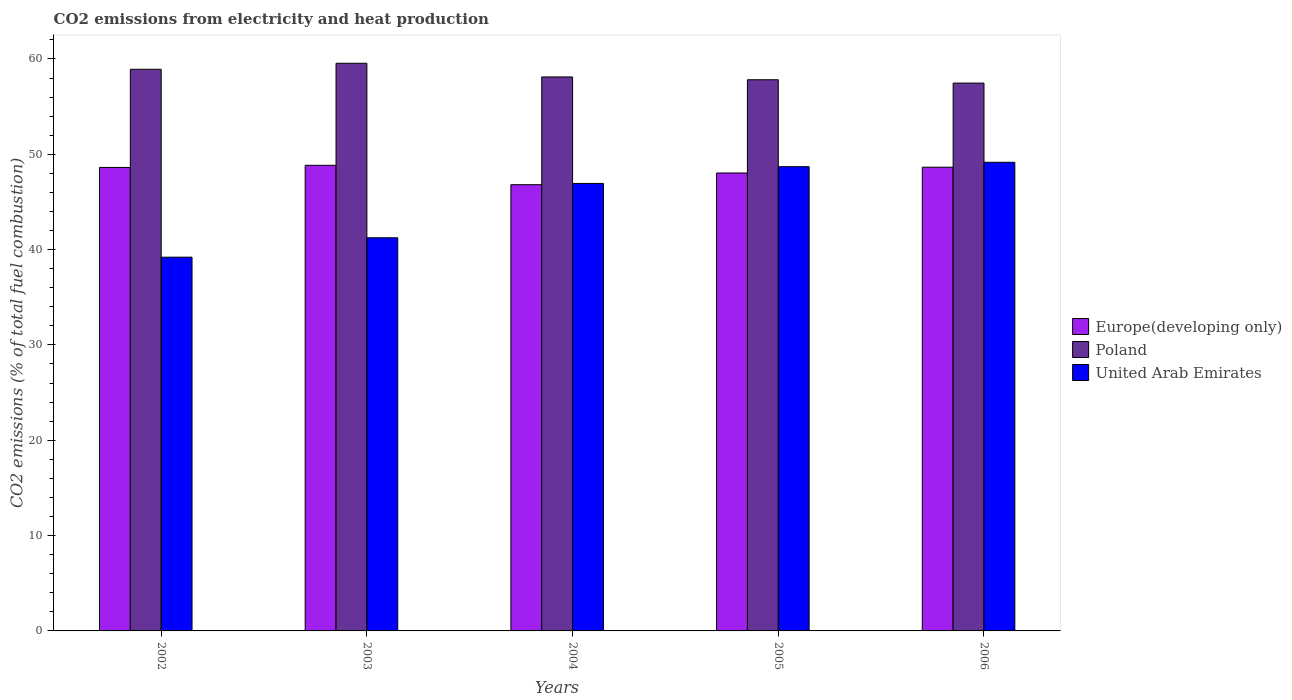How many different coloured bars are there?
Provide a succinct answer. 3. Are the number of bars on each tick of the X-axis equal?
Offer a very short reply. Yes. How many bars are there on the 1st tick from the right?
Ensure brevity in your answer.  3. What is the label of the 3rd group of bars from the left?
Your answer should be very brief. 2004. In how many cases, is the number of bars for a given year not equal to the number of legend labels?
Provide a succinct answer. 0. What is the amount of CO2 emitted in Poland in 2006?
Your answer should be very brief. 57.47. Across all years, what is the maximum amount of CO2 emitted in Europe(developing only)?
Provide a succinct answer. 48.84. Across all years, what is the minimum amount of CO2 emitted in Poland?
Make the answer very short. 57.47. In which year was the amount of CO2 emitted in Poland maximum?
Give a very brief answer. 2003. In which year was the amount of CO2 emitted in Europe(developing only) minimum?
Ensure brevity in your answer.  2004. What is the total amount of CO2 emitted in United Arab Emirates in the graph?
Provide a succinct answer. 225.24. What is the difference between the amount of CO2 emitted in Europe(developing only) in 2002 and that in 2005?
Your response must be concise. 0.58. What is the difference between the amount of CO2 emitted in United Arab Emirates in 2005 and the amount of CO2 emitted in Europe(developing only) in 2003?
Provide a short and direct response. -0.14. What is the average amount of CO2 emitted in Poland per year?
Your answer should be compact. 58.37. In the year 2003, what is the difference between the amount of CO2 emitted in United Arab Emirates and amount of CO2 emitted in Europe(developing only)?
Give a very brief answer. -7.6. In how many years, is the amount of CO2 emitted in Poland greater than 40 %?
Your answer should be compact. 5. What is the ratio of the amount of CO2 emitted in Europe(developing only) in 2003 to that in 2006?
Keep it short and to the point. 1. Is the amount of CO2 emitted in Poland in 2002 less than that in 2003?
Keep it short and to the point. Yes. Is the difference between the amount of CO2 emitted in United Arab Emirates in 2003 and 2005 greater than the difference between the amount of CO2 emitted in Europe(developing only) in 2003 and 2005?
Give a very brief answer. No. What is the difference between the highest and the second highest amount of CO2 emitted in Europe(developing only)?
Offer a terse response. 0.2. What is the difference between the highest and the lowest amount of CO2 emitted in Poland?
Provide a short and direct response. 2.08. In how many years, is the amount of CO2 emitted in Europe(developing only) greater than the average amount of CO2 emitted in Europe(developing only) taken over all years?
Offer a very short reply. 3. Is the sum of the amount of CO2 emitted in United Arab Emirates in 2003 and 2004 greater than the maximum amount of CO2 emitted in Europe(developing only) across all years?
Offer a terse response. Yes. What does the 2nd bar from the left in 2006 represents?
Provide a short and direct response. Poland. What does the 3rd bar from the right in 2004 represents?
Your answer should be compact. Europe(developing only). Is it the case that in every year, the sum of the amount of CO2 emitted in Europe(developing only) and amount of CO2 emitted in Poland is greater than the amount of CO2 emitted in United Arab Emirates?
Give a very brief answer. Yes. How many bars are there?
Keep it short and to the point. 15. Are all the bars in the graph horizontal?
Keep it short and to the point. No. How many years are there in the graph?
Provide a short and direct response. 5. Are the values on the major ticks of Y-axis written in scientific E-notation?
Provide a succinct answer. No. Does the graph contain grids?
Offer a very short reply. No. How many legend labels are there?
Offer a terse response. 3. How are the legend labels stacked?
Make the answer very short. Vertical. What is the title of the graph?
Keep it short and to the point. CO2 emissions from electricity and heat production. What is the label or title of the Y-axis?
Your answer should be compact. CO2 emissions (% of total fuel combustion). What is the CO2 emissions (% of total fuel combustion) in Europe(developing only) in 2002?
Make the answer very short. 48.62. What is the CO2 emissions (% of total fuel combustion) of Poland in 2002?
Offer a terse response. 58.92. What is the CO2 emissions (% of total fuel combustion) in United Arab Emirates in 2002?
Your response must be concise. 39.2. What is the CO2 emissions (% of total fuel combustion) of Europe(developing only) in 2003?
Give a very brief answer. 48.84. What is the CO2 emissions (% of total fuel combustion) in Poland in 2003?
Your response must be concise. 59.55. What is the CO2 emissions (% of total fuel combustion) in United Arab Emirates in 2003?
Keep it short and to the point. 41.24. What is the CO2 emissions (% of total fuel combustion) in Europe(developing only) in 2004?
Keep it short and to the point. 46.81. What is the CO2 emissions (% of total fuel combustion) in Poland in 2004?
Offer a very short reply. 58.11. What is the CO2 emissions (% of total fuel combustion) of United Arab Emirates in 2004?
Provide a succinct answer. 46.94. What is the CO2 emissions (% of total fuel combustion) in Europe(developing only) in 2005?
Keep it short and to the point. 48.04. What is the CO2 emissions (% of total fuel combustion) in Poland in 2005?
Make the answer very short. 57.82. What is the CO2 emissions (% of total fuel combustion) of United Arab Emirates in 2005?
Your answer should be very brief. 48.7. What is the CO2 emissions (% of total fuel combustion) of Europe(developing only) in 2006?
Offer a terse response. 48.64. What is the CO2 emissions (% of total fuel combustion) of Poland in 2006?
Offer a terse response. 57.47. What is the CO2 emissions (% of total fuel combustion) in United Arab Emirates in 2006?
Offer a very short reply. 49.16. Across all years, what is the maximum CO2 emissions (% of total fuel combustion) in Europe(developing only)?
Your response must be concise. 48.84. Across all years, what is the maximum CO2 emissions (% of total fuel combustion) of Poland?
Give a very brief answer. 59.55. Across all years, what is the maximum CO2 emissions (% of total fuel combustion) of United Arab Emirates?
Make the answer very short. 49.16. Across all years, what is the minimum CO2 emissions (% of total fuel combustion) of Europe(developing only)?
Your answer should be compact. 46.81. Across all years, what is the minimum CO2 emissions (% of total fuel combustion) in Poland?
Your answer should be compact. 57.47. Across all years, what is the minimum CO2 emissions (% of total fuel combustion) in United Arab Emirates?
Provide a short and direct response. 39.2. What is the total CO2 emissions (% of total fuel combustion) in Europe(developing only) in the graph?
Keep it short and to the point. 240.95. What is the total CO2 emissions (% of total fuel combustion) of Poland in the graph?
Your answer should be very brief. 291.86. What is the total CO2 emissions (% of total fuel combustion) in United Arab Emirates in the graph?
Keep it short and to the point. 225.24. What is the difference between the CO2 emissions (% of total fuel combustion) in Europe(developing only) in 2002 and that in 2003?
Offer a terse response. -0.22. What is the difference between the CO2 emissions (% of total fuel combustion) in Poland in 2002 and that in 2003?
Make the answer very short. -0.63. What is the difference between the CO2 emissions (% of total fuel combustion) in United Arab Emirates in 2002 and that in 2003?
Your answer should be compact. -2.04. What is the difference between the CO2 emissions (% of total fuel combustion) in Europe(developing only) in 2002 and that in 2004?
Ensure brevity in your answer.  1.81. What is the difference between the CO2 emissions (% of total fuel combustion) of Poland in 2002 and that in 2004?
Your answer should be compact. 0.81. What is the difference between the CO2 emissions (% of total fuel combustion) of United Arab Emirates in 2002 and that in 2004?
Provide a succinct answer. -7.74. What is the difference between the CO2 emissions (% of total fuel combustion) of Europe(developing only) in 2002 and that in 2005?
Provide a short and direct response. 0.58. What is the difference between the CO2 emissions (% of total fuel combustion) of Poland in 2002 and that in 2005?
Keep it short and to the point. 1.1. What is the difference between the CO2 emissions (% of total fuel combustion) in United Arab Emirates in 2002 and that in 2005?
Ensure brevity in your answer.  -9.49. What is the difference between the CO2 emissions (% of total fuel combustion) of Europe(developing only) in 2002 and that in 2006?
Provide a succinct answer. -0.02. What is the difference between the CO2 emissions (% of total fuel combustion) in Poland in 2002 and that in 2006?
Your answer should be compact. 1.45. What is the difference between the CO2 emissions (% of total fuel combustion) in United Arab Emirates in 2002 and that in 2006?
Ensure brevity in your answer.  -9.95. What is the difference between the CO2 emissions (% of total fuel combustion) in Europe(developing only) in 2003 and that in 2004?
Provide a short and direct response. 2.03. What is the difference between the CO2 emissions (% of total fuel combustion) of Poland in 2003 and that in 2004?
Offer a very short reply. 1.44. What is the difference between the CO2 emissions (% of total fuel combustion) of United Arab Emirates in 2003 and that in 2004?
Offer a terse response. -5.7. What is the difference between the CO2 emissions (% of total fuel combustion) of Europe(developing only) in 2003 and that in 2005?
Offer a very short reply. 0.81. What is the difference between the CO2 emissions (% of total fuel combustion) of Poland in 2003 and that in 2005?
Offer a very short reply. 1.73. What is the difference between the CO2 emissions (% of total fuel combustion) in United Arab Emirates in 2003 and that in 2005?
Offer a very short reply. -7.46. What is the difference between the CO2 emissions (% of total fuel combustion) of Europe(developing only) in 2003 and that in 2006?
Keep it short and to the point. 0.2. What is the difference between the CO2 emissions (% of total fuel combustion) in Poland in 2003 and that in 2006?
Provide a succinct answer. 2.08. What is the difference between the CO2 emissions (% of total fuel combustion) in United Arab Emirates in 2003 and that in 2006?
Provide a succinct answer. -7.92. What is the difference between the CO2 emissions (% of total fuel combustion) of Europe(developing only) in 2004 and that in 2005?
Your answer should be very brief. -1.23. What is the difference between the CO2 emissions (% of total fuel combustion) of Poland in 2004 and that in 2005?
Provide a succinct answer. 0.29. What is the difference between the CO2 emissions (% of total fuel combustion) of United Arab Emirates in 2004 and that in 2005?
Keep it short and to the point. -1.76. What is the difference between the CO2 emissions (% of total fuel combustion) of Europe(developing only) in 2004 and that in 2006?
Your response must be concise. -1.83. What is the difference between the CO2 emissions (% of total fuel combustion) in Poland in 2004 and that in 2006?
Provide a succinct answer. 0.64. What is the difference between the CO2 emissions (% of total fuel combustion) of United Arab Emirates in 2004 and that in 2006?
Offer a very short reply. -2.22. What is the difference between the CO2 emissions (% of total fuel combustion) of Europe(developing only) in 2005 and that in 2006?
Make the answer very short. -0.61. What is the difference between the CO2 emissions (% of total fuel combustion) in Poland in 2005 and that in 2006?
Your answer should be compact. 0.35. What is the difference between the CO2 emissions (% of total fuel combustion) in United Arab Emirates in 2005 and that in 2006?
Keep it short and to the point. -0.46. What is the difference between the CO2 emissions (% of total fuel combustion) of Europe(developing only) in 2002 and the CO2 emissions (% of total fuel combustion) of Poland in 2003?
Make the answer very short. -10.93. What is the difference between the CO2 emissions (% of total fuel combustion) of Europe(developing only) in 2002 and the CO2 emissions (% of total fuel combustion) of United Arab Emirates in 2003?
Your answer should be compact. 7.38. What is the difference between the CO2 emissions (% of total fuel combustion) in Poland in 2002 and the CO2 emissions (% of total fuel combustion) in United Arab Emirates in 2003?
Offer a very short reply. 17.68. What is the difference between the CO2 emissions (% of total fuel combustion) of Europe(developing only) in 2002 and the CO2 emissions (% of total fuel combustion) of Poland in 2004?
Offer a very short reply. -9.49. What is the difference between the CO2 emissions (% of total fuel combustion) in Europe(developing only) in 2002 and the CO2 emissions (% of total fuel combustion) in United Arab Emirates in 2004?
Your answer should be compact. 1.68. What is the difference between the CO2 emissions (% of total fuel combustion) of Poland in 2002 and the CO2 emissions (% of total fuel combustion) of United Arab Emirates in 2004?
Provide a succinct answer. 11.97. What is the difference between the CO2 emissions (% of total fuel combustion) of Europe(developing only) in 2002 and the CO2 emissions (% of total fuel combustion) of Poland in 2005?
Keep it short and to the point. -9.2. What is the difference between the CO2 emissions (% of total fuel combustion) in Europe(developing only) in 2002 and the CO2 emissions (% of total fuel combustion) in United Arab Emirates in 2005?
Offer a terse response. -0.08. What is the difference between the CO2 emissions (% of total fuel combustion) in Poland in 2002 and the CO2 emissions (% of total fuel combustion) in United Arab Emirates in 2005?
Make the answer very short. 10.22. What is the difference between the CO2 emissions (% of total fuel combustion) in Europe(developing only) in 2002 and the CO2 emissions (% of total fuel combustion) in Poland in 2006?
Give a very brief answer. -8.85. What is the difference between the CO2 emissions (% of total fuel combustion) of Europe(developing only) in 2002 and the CO2 emissions (% of total fuel combustion) of United Arab Emirates in 2006?
Provide a succinct answer. -0.54. What is the difference between the CO2 emissions (% of total fuel combustion) in Poland in 2002 and the CO2 emissions (% of total fuel combustion) in United Arab Emirates in 2006?
Your response must be concise. 9.76. What is the difference between the CO2 emissions (% of total fuel combustion) of Europe(developing only) in 2003 and the CO2 emissions (% of total fuel combustion) of Poland in 2004?
Ensure brevity in your answer.  -9.27. What is the difference between the CO2 emissions (% of total fuel combustion) of Europe(developing only) in 2003 and the CO2 emissions (% of total fuel combustion) of United Arab Emirates in 2004?
Your response must be concise. 1.9. What is the difference between the CO2 emissions (% of total fuel combustion) in Poland in 2003 and the CO2 emissions (% of total fuel combustion) in United Arab Emirates in 2004?
Offer a very short reply. 12.61. What is the difference between the CO2 emissions (% of total fuel combustion) of Europe(developing only) in 2003 and the CO2 emissions (% of total fuel combustion) of Poland in 2005?
Give a very brief answer. -8.97. What is the difference between the CO2 emissions (% of total fuel combustion) in Europe(developing only) in 2003 and the CO2 emissions (% of total fuel combustion) in United Arab Emirates in 2005?
Give a very brief answer. 0.14. What is the difference between the CO2 emissions (% of total fuel combustion) in Poland in 2003 and the CO2 emissions (% of total fuel combustion) in United Arab Emirates in 2005?
Keep it short and to the point. 10.85. What is the difference between the CO2 emissions (% of total fuel combustion) in Europe(developing only) in 2003 and the CO2 emissions (% of total fuel combustion) in Poland in 2006?
Ensure brevity in your answer.  -8.62. What is the difference between the CO2 emissions (% of total fuel combustion) in Europe(developing only) in 2003 and the CO2 emissions (% of total fuel combustion) in United Arab Emirates in 2006?
Your response must be concise. -0.32. What is the difference between the CO2 emissions (% of total fuel combustion) of Poland in 2003 and the CO2 emissions (% of total fuel combustion) of United Arab Emirates in 2006?
Offer a very short reply. 10.39. What is the difference between the CO2 emissions (% of total fuel combustion) in Europe(developing only) in 2004 and the CO2 emissions (% of total fuel combustion) in Poland in 2005?
Ensure brevity in your answer.  -11.01. What is the difference between the CO2 emissions (% of total fuel combustion) in Europe(developing only) in 2004 and the CO2 emissions (% of total fuel combustion) in United Arab Emirates in 2005?
Offer a terse response. -1.89. What is the difference between the CO2 emissions (% of total fuel combustion) in Poland in 2004 and the CO2 emissions (% of total fuel combustion) in United Arab Emirates in 2005?
Your answer should be compact. 9.41. What is the difference between the CO2 emissions (% of total fuel combustion) in Europe(developing only) in 2004 and the CO2 emissions (% of total fuel combustion) in Poland in 2006?
Offer a terse response. -10.66. What is the difference between the CO2 emissions (% of total fuel combustion) of Europe(developing only) in 2004 and the CO2 emissions (% of total fuel combustion) of United Arab Emirates in 2006?
Your answer should be very brief. -2.35. What is the difference between the CO2 emissions (% of total fuel combustion) of Poland in 2004 and the CO2 emissions (% of total fuel combustion) of United Arab Emirates in 2006?
Provide a succinct answer. 8.95. What is the difference between the CO2 emissions (% of total fuel combustion) of Europe(developing only) in 2005 and the CO2 emissions (% of total fuel combustion) of Poland in 2006?
Offer a terse response. -9.43. What is the difference between the CO2 emissions (% of total fuel combustion) in Europe(developing only) in 2005 and the CO2 emissions (% of total fuel combustion) in United Arab Emirates in 2006?
Your response must be concise. -1.12. What is the difference between the CO2 emissions (% of total fuel combustion) in Poland in 2005 and the CO2 emissions (% of total fuel combustion) in United Arab Emirates in 2006?
Ensure brevity in your answer.  8.66. What is the average CO2 emissions (% of total fuel combustion) of Europe(developing only) per year?
Offer a very short reply. 48.19. What is the average CO2 emissions (% of total fuel combustion) of Poland per year?
Provide a short and direct response. 58.37. What is the average CO2 emissions (% of total fuel combustion) in United Arab Emirates per year?
Ensure brevity in your answer.  45.05. In the year 2002, what is the difference between the CO2 emissions (% of total fuel combustion) in Europe(developing only) and CO2 emissions (% of total fuel combustion) in Poland?
Your answer should be compact. -10.3. In the year 2002, what is the difference between the CO2 emissions (% of total fuel combustion) of Europe(developing only) and CO2 emissions (% of total fuel combustion) of United Arab Emirates?
Keep it short and to the point. 9.41. In the year 2002, what is the difference between the CO2 emissions (% of total fuel combustion) in Poland and CO2 emissions (% of total fuel combustion) in United Arab Emirates?
Provide a succinct answer. 19.71. In the year 2003, what is the difference between the CO2 emissions (% of total fuel combustion) in Europe(developing only) and CO2 emissions (% of total fuel combustion) in Poland?
Provide a succinct answer. -10.7. In the year 2003, what is the difference between the CO2 emissions (% of total fuel combustion) in Europe(developing only) and CO2 emissions (% of total fuel combustion) in United Arab Emirates?
Keep it short and to the point. 7.6. In the year 2003, what is the difference between the CO2 emissions (% of total fuel combustion) of Poland and CO2 emissions (% of total fuel combustion) of United Arab Emirates?
Provide a short and direct response. 18.31. In the year 2004, what is the difference between the CO2 emissions (% of total fuel combustion) of Europe(developing only) and CO2 emissions (% of total fuel combustion) of Poland?
Provide a short and direct response. -11.3. In the year 2004, what is the difference between the CO2 emissions (% of total fuel combustion) of Europe(developing only) and CO2 emissions (% of total fuel combustion) of United Arab Emirates?
Ensure brevity in your answer.  -0.13. In the year 2004, what is the difference between the CO2 emissions (% of total fuel combustion) of Poland and CO2 emissions (% of total fuel combustion) of United Arab Emirates?
Ensure brevity in your answer.  11.17. In the year 2005, what is the difference between the CO2 emissions (% of total fuel combustion) in Europe(developing only) and CO2 emissions (% of total fuel combustion) in Poland?
Provide a short and direct response. -9.78. In the year 2005, what is the difference between the CO2 emissions (% of total fuel combustion) in Europe(developing only) and CO2 emissions (% of total fuel combustion) in United Arab Emirates?
Provide a short and direct response. -0.66. In the year 2005, what is the difference between the CO2 emissions (% of total fuel combustion) in Poland and CO2 emissions (% of total fuel combustion) in United Arab Emirates?
Provide a succinct answer. 9.12. In the year 2006, what is the difference between the CO2 emissions (% of total fuel combustion) of Europe(developing only) and CO2 emissions (% of total fuel combustion) of Poland?
Offer a very short reply. -8.82. In the year 2006, what is the difference between the CO2 emissions (% of total fuel combustion) in Europe(developing only) and CO2 emissions (% of total fuel combustion) in United Arab Emirates?
Provide a succinct answer. -0.52. In the year 2006, what is the difference between the CO2 emissions (% of total fuel combustion) of Poland and CO2 emissions (% of total fuel combustion) of United Arab Emirates?
Your answer should be very brief. 8.31. What is the ratio of the CO2 emissions (% of total fuel combustion) in Europe(developing only) in 2002 to that in 2003?
Offer a terse response. 1. What is the ratio of the CO2 emissions (% of total fuel combustion) of Poland in 2002 to that in 2003?
Your answer should be very brief. 0.99. What is the ratio of the CO2 emissions (% of total fuel combustion) in United Arab Emirates in 2002 to that in 2003?
Your answer should be very brief. 0.95. What is the ratio of the CO2 emissions (% of total fuel combustion) of Europe(developing only) in 2002 to that in 2004?
Your response must be concise. 1.04. What is the ratio of the CO2 emissions (% of total fuel combustion) of Poland in 2002 to that in 2004?
Your answer should be compact. 1.01. What is the ratio of the CO2 emissions (% of total fuel combustion) in United Arab Emirates in 2002 to that in 2004?
Your answer should be very brief. 0.84. What is the ratio of the CO2 emissions (% of total fuel combustion) in Europe(developing only) in 2002 to that in 2005?
Offer a terse response. 1.01. What is the ratio of the CO2 emissions (% of total fuel combustion) of United Arab Emirates in 2002 to that in 2005?
Ensure brevity in your answer.  0.81. What is the ratio of the CO2 emissions (% of total fuel combustion) in Europe(developing only) in 2002 to that in 2006?
Make the answer very short. 1. What is the ratio of the CO2 emissions (% of total fuel combustion) in Poland in 2002 to that in 2006?
Provide a short and direct response. 1.03. What is the ratio of the CO2 emissions (% of total fuel combustion) in United Arab Emirates in 2002 to that in 2006?
Your answer should be compact. 0.8. What is the ratio of the CO2 emissions (% of total fuel combustion) in Europe(developing only) in 2003 to that in 2004?
Ensure brevity in your answer.  1.04. What is the ratio of the CO2 emissions (% of total fuel combustion) of Poland in 2003 to that in 2004?
Provide a succinct answer. 1.02. What is the ratio of the CO2 emissions (% of total fuel combustion) in United Arab Emirates in 2003 to that in 2004?
Ensure brevity in your answer.  0.88. What is the ratio of the CO2 emissions (% of total fuel combustion) of Europe(developing only) in 2003 to that in 2005?
Offer a very short reply. 1.02. What is the ratio of the CO2 emissions (% of total fuel combustion) in Poland in 2003 to that in 2005?
Your response must be concise. 1.03. What is the ratio of the CO2 emissions (% of total fuel combustion) in United Arab Emirates in 2003 to that in 2005?
Give a very brief answer. 0.85. What is the ratio of the CO2 emissions (% of total fuel combustion) of Poland in 2003 to that in 2006?
Your response must be concise. 1.04. What is the ratio of the CO2 emissions (% of total fuel combustion) of United Arab Emirates in 2003 to that in 2006?
Your answer should be very brief. 0.84. What is the ratio of the CO2 emissions (% of total fuel combustion) in Europe(developing only) in 2004 to that in 2005?
Your answer should be very brief. 0.97. What is the ratio of the CO2 emissions (% of total fuel combustion) of United Arab Emirates in 2004 to that in 2005?
Provide a succinct answer. 0.96. What is the ratio of the CO2 emissions (% of total fuel combustion) in Europe(developing only) in 2004 to that in 2006?
Provide a succinct answer. 0.96. What is the ratio of the CO2 emissions (% of total fuel combustion) of Poland in 2004 to that in 2006?
Your response must be concise. 1.01. What is the ratio of the CO2 emissions (% of total fuel combustion) of United Arab Emirates in 2004 to that in 2006?
Offer a terse response. 0.95. What is the ratio of the CO2 emissions (% of total fuel combustion) of Europe(developing only) in 2005 to that in 2006?
Your answer should be very brief. 0.99. What is the ratio of the CO2 emissions (% of total fuel combustion) of United Arab Emirates in 2005 to that in 2006?
Keep it short and to the point. 0.99. What is the difference between the highest and the second highest CO2 emissions (% of total fuel combustion) of Europe(developing only)?
Give a very brief answer. 0.2. What is the difference between the highest and the second highest CO2 emissions (% of total fuel combustion) in Poland?
Provide a succinct answer. 0.63. What is the difference between the highest and the second highest CO2 emissions (% of total fuel combustion) in United Arab Emirates?
Ensure brevity in your answer.  0.46. What is the difference between the highest and the lowest CO2 emissions (% of total fuel combustion) of Europe(developing only)?
Offer a very short reply. 2.03. What is the difference between the highest and the lowest CO2 emissions (% of total fuel combustion) in Poland?
Your answer should be very brief. 2.08. What is the difference between the highest and the lowest CO2 emissions (% of total fuel combustion) of United Arab Emirates?
Make the answer very short. 9.95. 